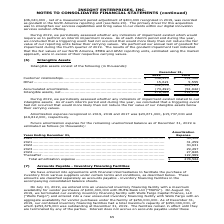According to Insight Enterprises's financial document, How much was the Amortization expense in 2019? According to the financial document, $23,671,000. The relevant text states: "tion expense recognized in 2019, 2018 and 2017 was $23,671,000, $15,737,000 and $16,812,000, respectively...." Also, How much was the Amortization expense in 2018? According to the financial document, $15,737,000. The relevant text states: "recognized in 2019, 2018 and 2017 was $23,671,000, $15,737,000 and $16,812,000, respectively...." Also, How much was the Amortization expense in 2017? According to the financial document, $16,812,000. The relevant text states: "19, 2018 and 2017 was $23,671,000, $15,737,000 and $16,812,000, respectively...." Also, can you calculate: What is the change in Accumulated amortization between 2018 and 2019? Based on the calculation: 73,492-52,942, the result is 20550 (in thousands). This is based on the information: "....................................... (73,492) (52,942) Intangible assets, net................................................................. 278,584 11 .............................................." The key data points involved are: 52,942, 73,492. Also, can you calculate: What is the change in Intangible assets, net between 2018 and 2019? Based on the calculation: 278,584-112,179, the result is 166405 (in thousands). This is based on the information: "......................................... 278,584 112,179 ................................................. 278,584 112,179..." The key data points involved are: 112,179, 278,584. Also, can you calculate: What is the average Accumulated amortization for 2018 and 2019? To answer this question, I need to perform calculations using the financial data. The calculation is: (73,492+52,942) / 2, which equals 63217 (in thousands). This is based on the information: "....................................... (73,492) (52,942) Intangible assets, net................................................................. 278,584 11 .............................................." The key data points involved are: 52,942, 73,492. 